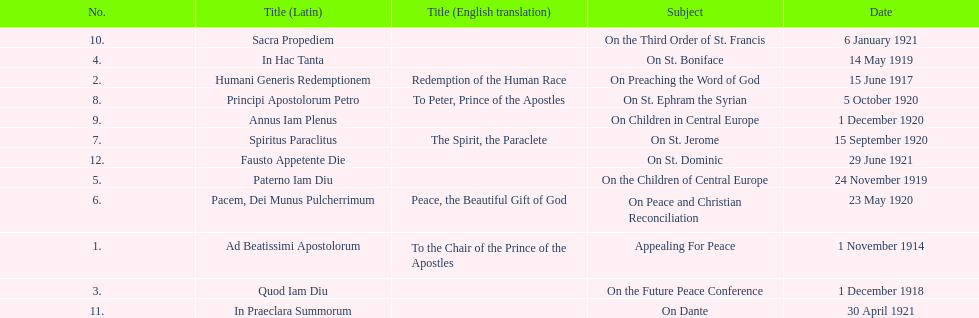What are all the subjects? Appealing For Peace, On Preaching the Word of God, On the Future Peace Conference, On St. Boniface, On the Children of Central Europe, On Peace and Christian Reconciliation, On St. Jerome, On St. Ephram the Syrian, On Children in Central Europe, On the Third Order of St. Francis, On Dante, On St. Dominic. Which occurred in 1920? On Peace and Christian Reconciliation, On St. Jerome, On St. Ephram the Syrian, On Children in Central Europe. Which occurred in may of that year? On Peace and Christian Reconciliation. 